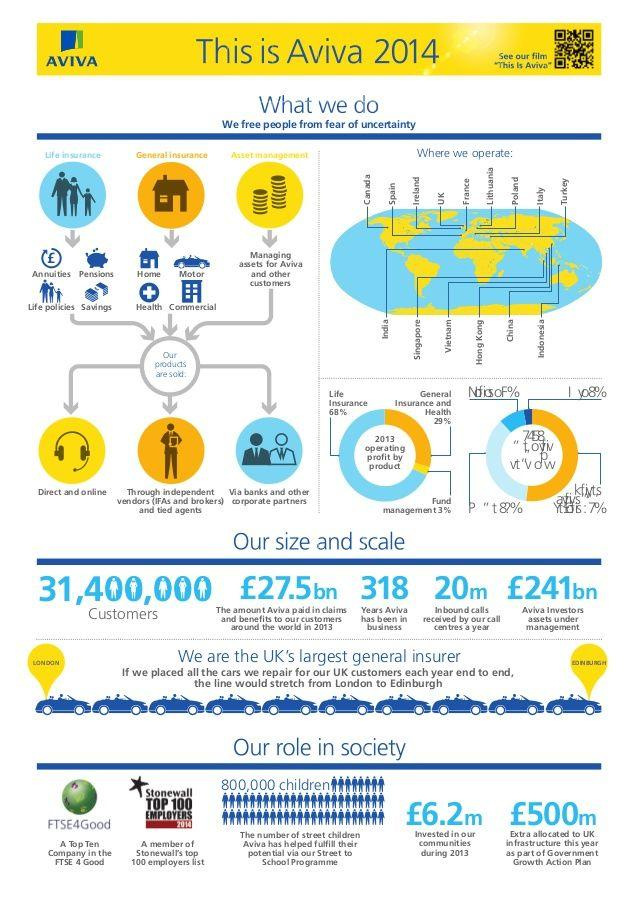Give some essential details in this illustration. Aviva has approximately 31.4 million customers. The operating profit from General Insurance and Health was 29%. Aviva offers three options for customers to purchase its products. The amount of 500 million pounds was allocated as part of the Government Action Plan. The operating profit from life insurance is 68%. 